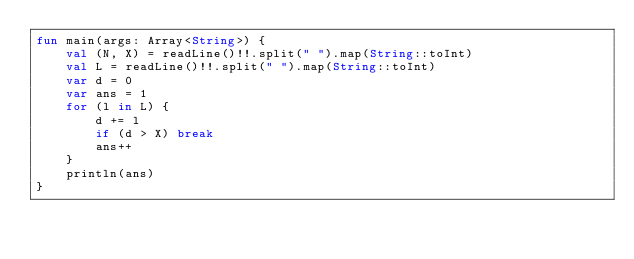<code> <loc_0><loc_0><loc_500><loc_500><_Kotlin_>fun main(args: Array<String>) {
    val (N, X) = readLine()!!.split(" ").map(String::toInt)
    val L = readLine()!!.split(" ").map(String::toInt)
    var d = 0
    var ans = 1
    for (l in L) {
        d += l
        if (d > X) break
        ans++
    }
    println(ans)
}</code> 